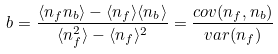Convert formula to latex. <formula><loc_0><loc_0><loc_500><loc_500>\ b = \frac { \langle n _ { f } n _ { b } \rangle - \langle n _ { f } \rangle \langle n _ { b } \rangle } { \langle n _ { f } ^ { 2 } \rangle - \langle n _ { f } \rangle ^ { 2 } } = \frac { c o v ( n _ { f } , n _ { b } ) } { v a r ( n _ { f } ) }</formula> 